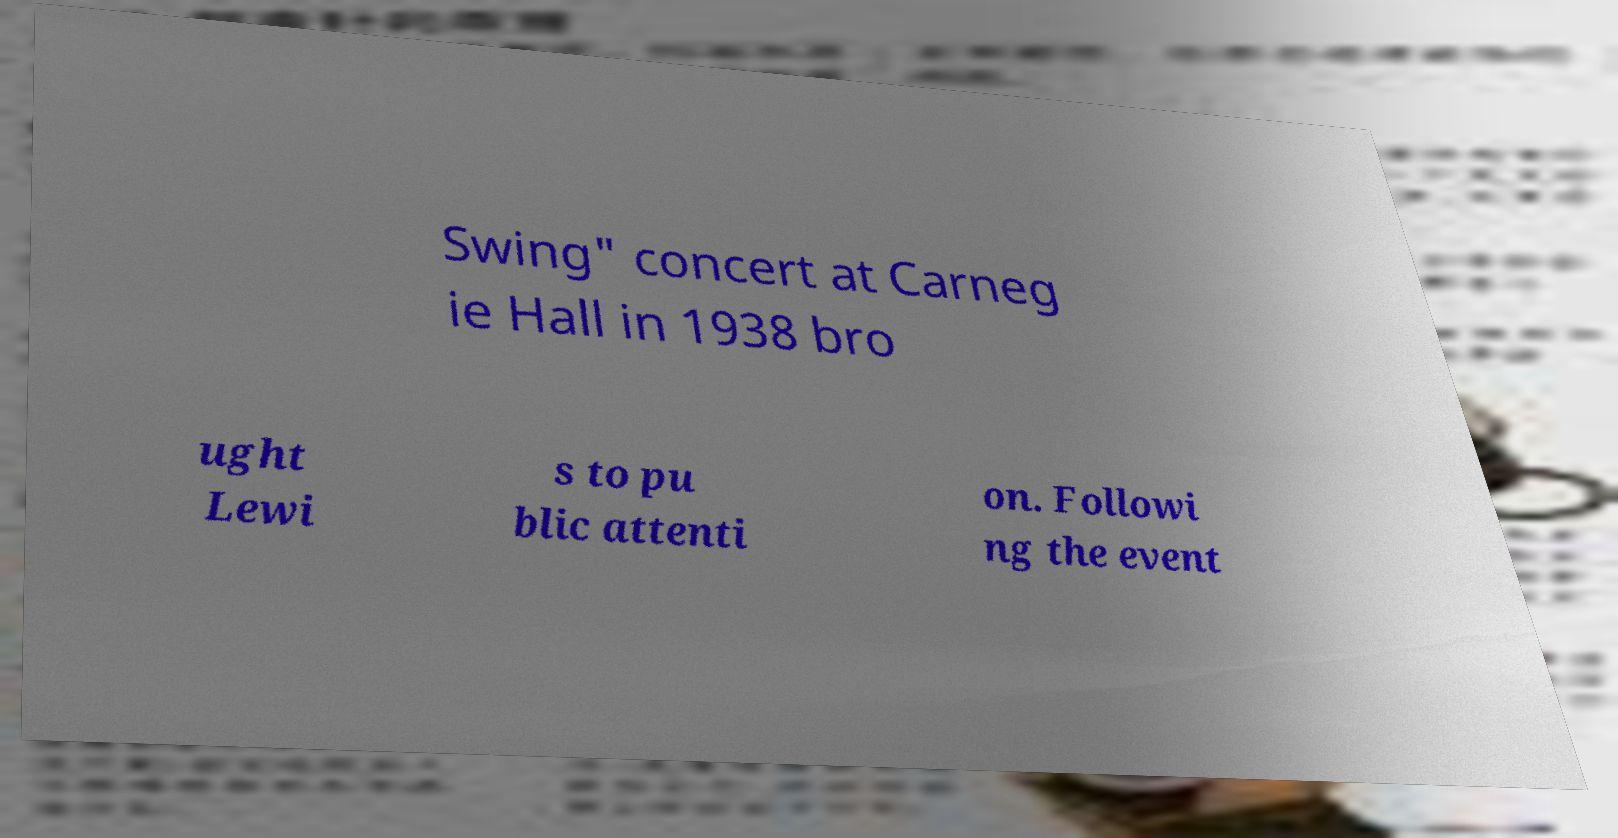Can you read and provide the text displayed in the image?This photo seems to have some interesting text. Can you extract and type it out for me? Swing" concert at Carneg ie Hall in 1938 bro ught Lewi s to pu blic attenti on. Followi ng the event 